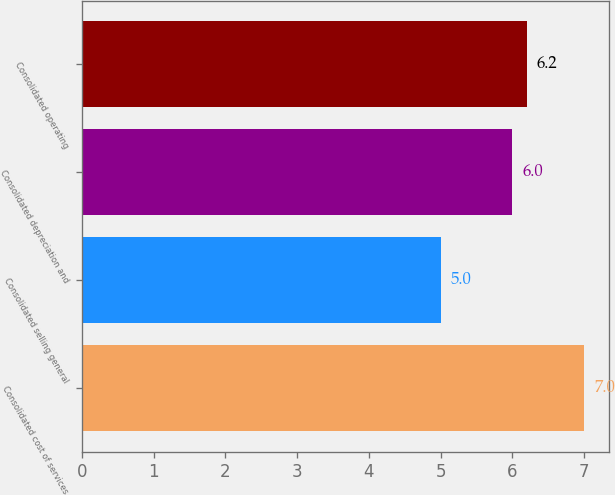Convert chart. <chart><loc_0><loc_0><loc_500><loc_500><bar_chart><fcel>Consolidated cost of services<fcel>Consolidated selling general<fcel>Consolidated depreciation and<fcel>Consolidated operating<nl><fcel>7<fcel>5<fcel>6<fcel>6.2<nl></chart> 